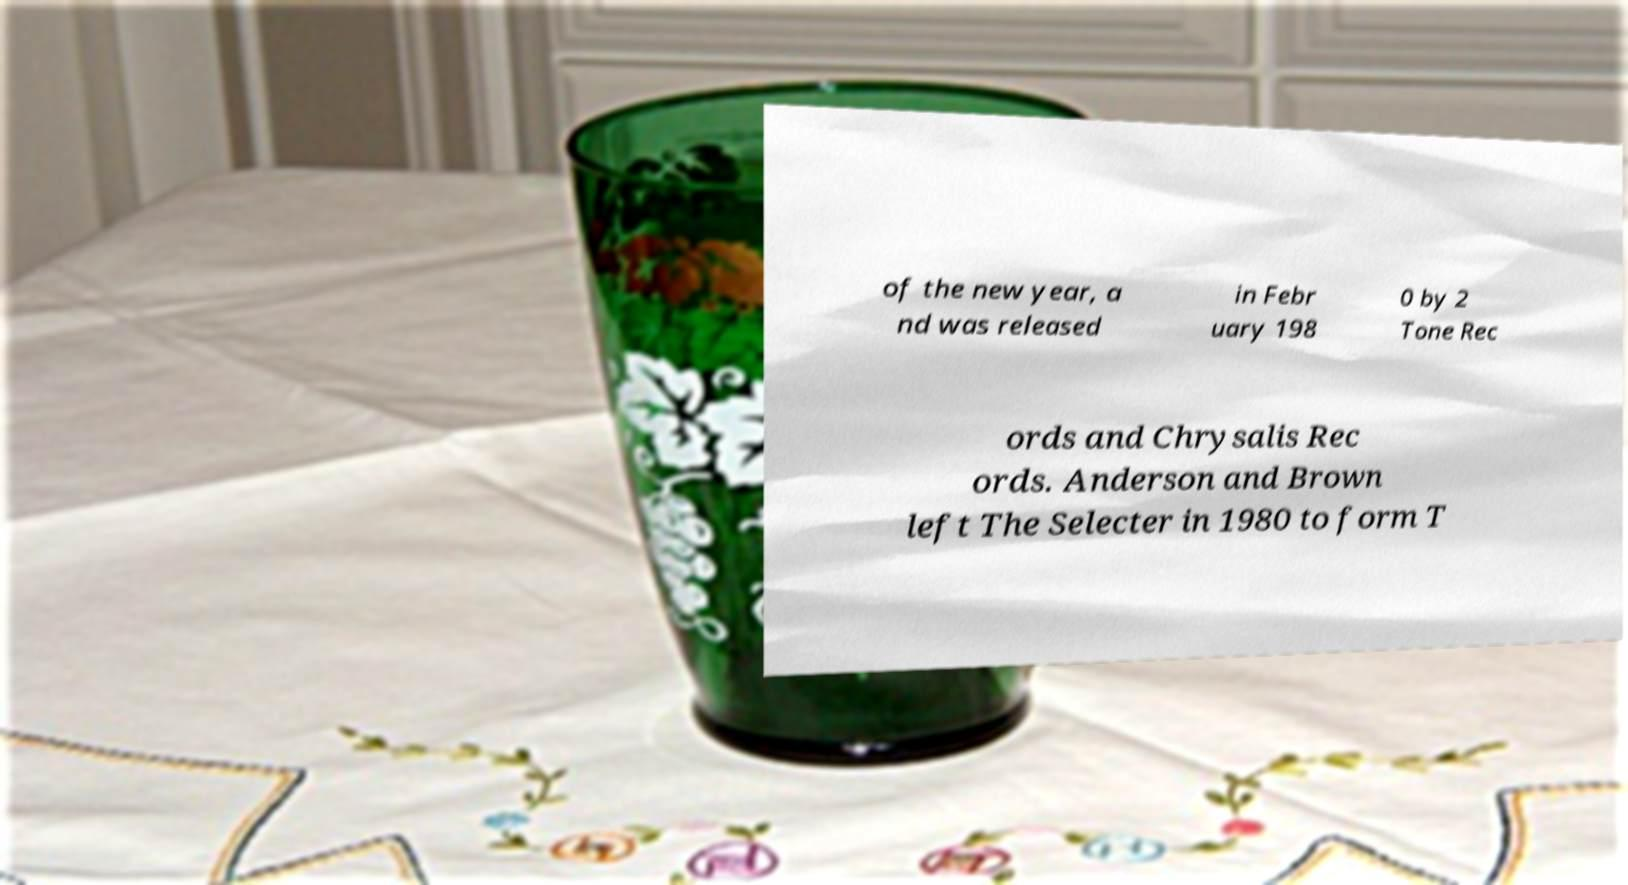Can you accurately transcribe the text from the provided image for me? of the new year, a nd was released in Febr uary 198 0 by 2 Tone Rec ords and Chrysalis Rec ords. Anderson and Brown left The Selecter in 1980 to form T 